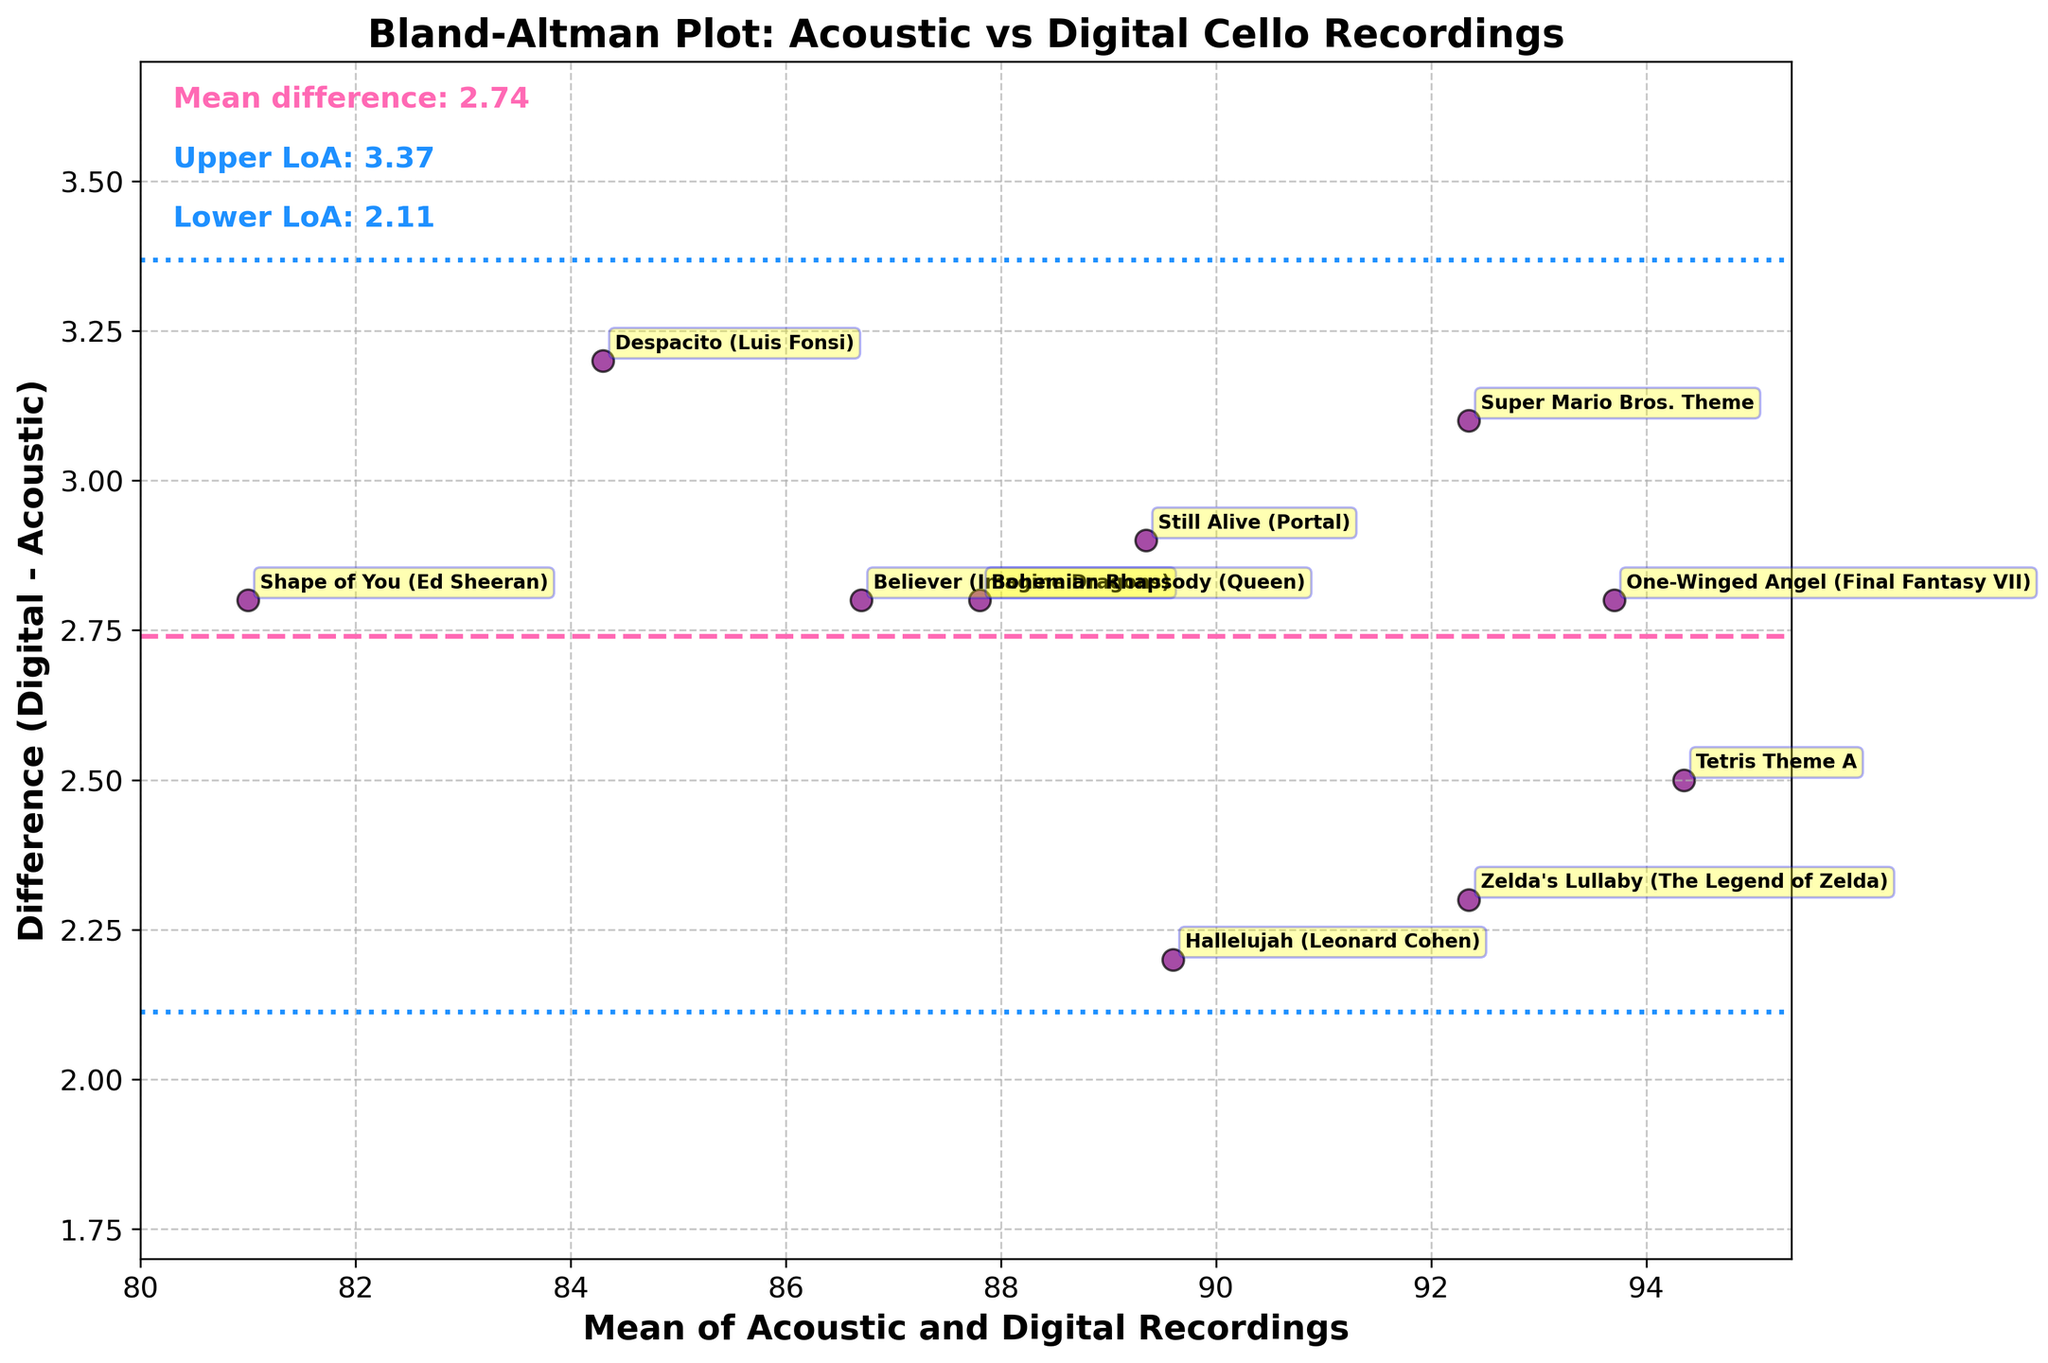How many data points are in the figure? The figure has data points for each of the songs listed in the data. To count the points, we observe there are 10 unique song titles provided.
Answer: 10 What is the title of the plot? The title of the plot is displayed at the top, which is 'Bland-Altman Plot: Acoustic vs Digital Cello Recordings'.
Answer: Bland-Altman Plot: Acoustic vs Digital Cello Recordings What colors are used for the mean difference and limits of agreement lines? The figure uses a dashed pink line for the mean difference and dotted blue lines for the limits of agreement.
Answer: Pink and blue Which song has the highest mean recording value? To determine this, we look at the data points and identify the one with the highest mean value. From the data provided, "Tetris Theme A" has the highest average of 94.35.
Answer: Tetris Theme A What is the mean value and difference for the song "Shape of You"? By looking at the annotated data points, “Shape of You” has a mean value of 81.0 and a difference of 2.8.
Answer: 81.0 and 2.8 What are the limits of agreement values shown in the plot? The plot visually indicates the limits of agreement as horizontal lines and the text annotations provide the numerical values. The lower limit is mean_diff - 1.96 * std_diff, and the upper limit is mean_diff + 1.96 * std_diff. These are approximately -0.08 and 3.88.
Answer: -0.08 and 3.88 Is there a song where the difference between acoustic and digital recordings is exactly the same as the mean difference of all recordings? The mean difference is indicated by the pink dashed line. The songs with a difference of 2.8 are "Believer", "Shape of You", "Bohemian Rhapsody", and "One-Winged Angel", matching the mean difference exactly.
Answer: Yes, four songs: "Believer", "Shape of You", "Bohemian Rhapsody", "One-Winged Angel" Are there any recordings with a difference lower than 2.5? Observing the scatter points below the 2.5 difference line, the songs with differences lower than 2.5 are "Zelda's Lullaby" and "Hallelujah".
Answer: Yes, "Zelda's Lullaby" and "Hallelujah" Which song has the largest difference between the digital and acoustic recordings? We look at the data point with the highest value on the y-axis (difference). "Despacito" has the largest difference of 3.2.
Answer: Despacito What range of mean values is covered by the plot? The x-axis shows the range of mean values, from the lowest to the highest mean value. The lowest mean is around 81.0 ("Shape of You") and the highest is around 94.35 ("Tetris Theme A").
Answer: Approx. 81.0 to 94.35 